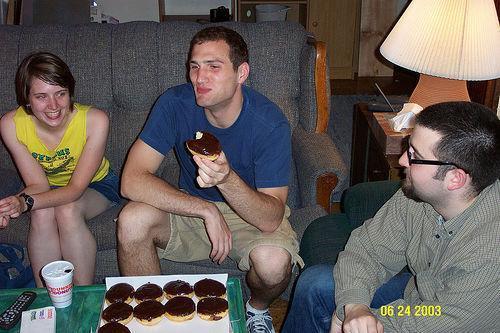How many people are wearing glasses?
Give a very brief answer. 1. How many people are pictured?
Give a very brief answer. 3. 